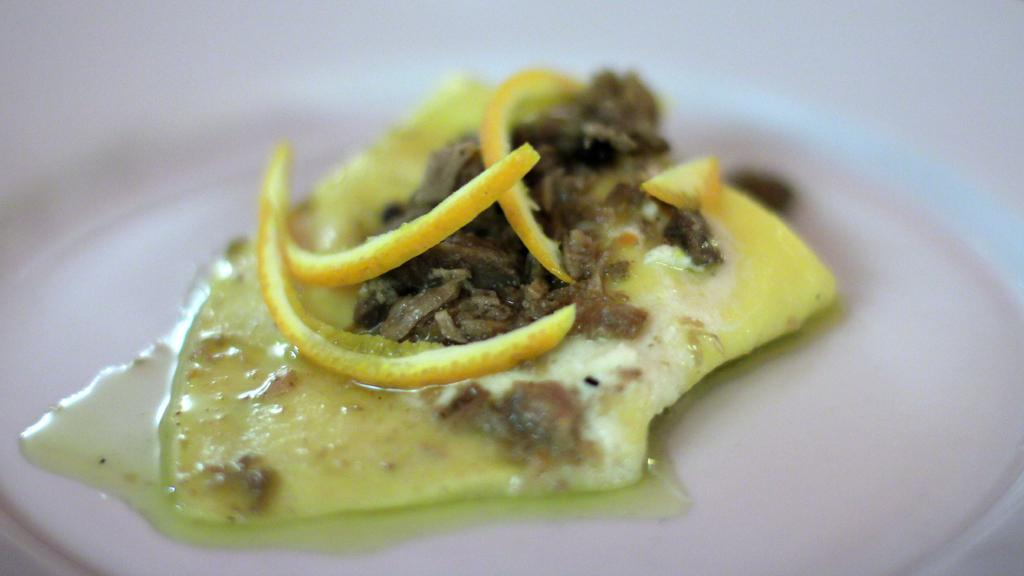What is the main subject of the image? The main subject of the image is food. Can you describe the background of the image? The background of the image is blurred. What type of patch is sewn onto the lawyer's jacket in the image? There is no lawyer or patch present in the image. Can you tell me how many zippers are visible on the food in the image? There are no zippers present on the food in the image. 